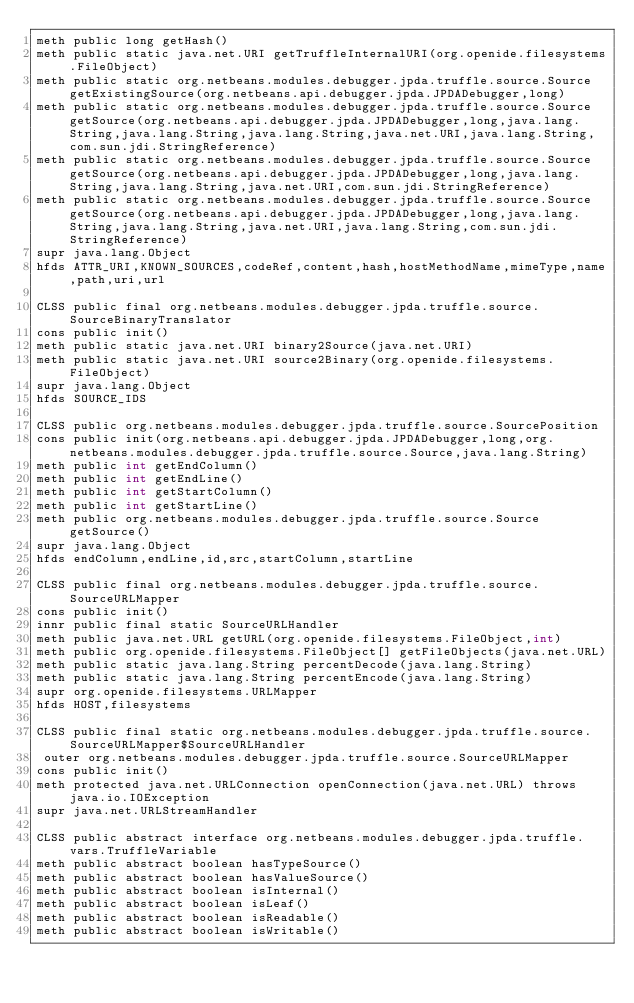Convert code to text. <code><loc_0><loc_0><loc_500><loc_500><_SML_>meth public long getHash()
meth public static java.net.URI getTruffleInternalURI(org.openide.filesystems.FileObject)
meth public static org.netbeans.modules.debugger.jpda.truffle.source.Source getExistingSource(org.netbeans.api.debugger.jpda.JPDADebugger,long)
meth public static org.netbeans.modules.debugger.jpda.truffle.source.Source getSource(org.netbeans.api.debugger.jpda.JPDADebugger,long,java.lang.String,java.lang.String,java.lang.String,java.net.URI,java.lang.String,com.sun.jdi.StringReference)
meth public static org.netbeans.modules.debugger.jpda.truffle.source.Source getSource(org.netbeans.api.debugger.jpda.JPDADebugger,long,java.lang.String,java.lang.String,java.net.URI,com.sun.jdi.StringReference)
meth public static org.netbeans.modules.debugger.jpda.truffle.source.Source getSource(org.netbeans.api.debugger.jpda.JPDADebugger,long,java.lang.String,java.lang.String,java.net.URI,java.lang.String,com.sun.jdi.StringReference)
supr java.lang.Object
hfds ATTR_URI,KNOWN_SOURCES,codeRef,content,hash,hostMethodName,mimeType,name,path,uri,url

CLSS public final org.netbeans.modules.debugger.jpda.truffle.source.SourceBinaryTranslator
cons public init()
meth public static java.net.URI binary2Source(java.net.URI)
meth public static java.net.URI source2Binary(org.openide.filesystems.FileObject)
supr java.lang.Object
hfds SOURCE_IDS

CLSS public org.netbeans.modules.debugger.jpda.truffle.source.SourcePosition
cons public init(org.netbeans.api.debugger.jpda.JPDADebugger,long,org.netbeans.modules.debugger.jpda.truffle.source.Source,java.lang.String)
meth public int getEndColumn()
meth public int getEndLine()
meth public int getStartColumn()
meth public int getStartLine()
meth public org.netbeans.modules.debugger.jpda.truffle.source.Source getSource()
supr java.lang.Object
hfds endColumn,endLine,id,src,startColumn,startLine

CLSS public final org.netbeans.modules.debugger.jpda.truffle.source.SourceURLMapper
cons public init()
innr public final static SourceURLHandler
meth public java.net.URL getURL(org.openide.filesystems.FileObject,int)
meth public org.openide.filesystems.FileObject[] getFileObjects(java.net.URL)
meth public static java.lang.String percentDecode(java.lang.String)
meth public static java.lang.String percentEncode(java.lang.String)
supr org.openide.filesystems.URLMapper
hfds HOST,filesystems

CLSS public final static org.netbeans.modules.debugger.jpda.truffle.source.SourceURLMapper$SourceURLHandler
 outer org.netbeans.modules.debugger.jpda.truffle.source.SourceURLMapper
cons public init()
meth protected java.net.URLConnection openConnection(java.net.URL) throws java.io.IOException
supr java.net.URLStreamHandler

CLSS public abstract interface org.netbeans.modules.debugger.jpda.truffle.vars.TruffleVariable
meth public abstract boolean hasTypeSource()
meth public abstract boolean hasValueSource()
meth public abstract boolean isInternal()
meth public abstract boolean isLeaf()
meth public abstract boolean isReadable()
meth public abstract boolean isWritable()</code> 